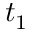Convert formula to latex. <formula><loc_0><loc_0><loc_500><loc_500>t _ { 1 }</formula> 